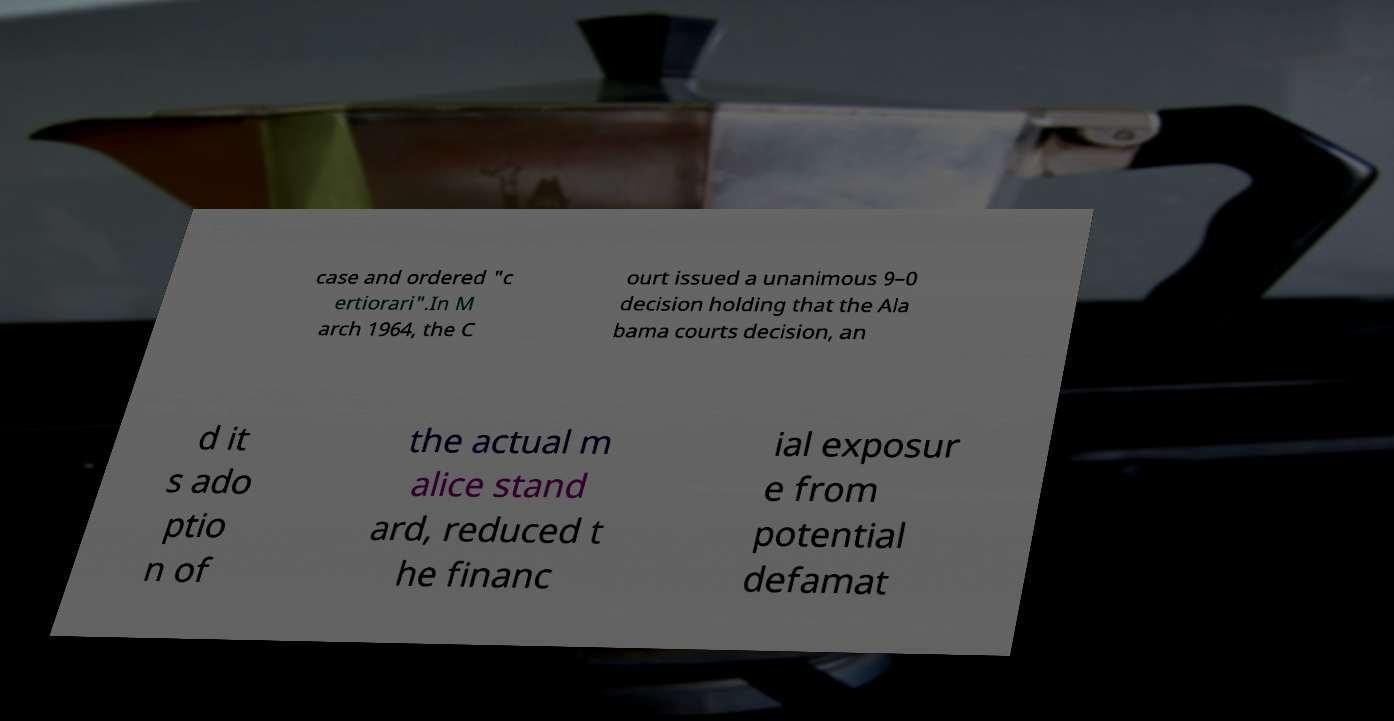Can you read and provide the text displayed in the image?This photo seems to have some interesting text. Can you extract and type it out for me? case and ordered "c ertiorari".In M arch 1964, the C ourt issued a unanimous 9–0 decision holding that the Ala bama courts decision, an d it s ado ptio n of the actual m alice stand ard, reduced t he financ ial exposur e from potential defamat 